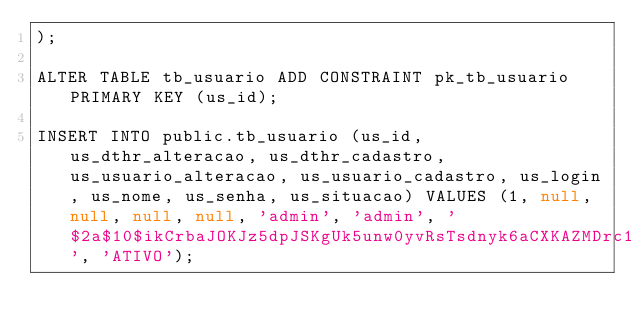<code> <loc_0><loc_0><loc_500><loc_500><_SQL_>);

ALTER TABLE tb_usuario ADD CONSTRAINT pk_tb_usuario PRIMARY KEY (us_id);

INSERT INTO public.tb_usuario (us_id, us_dthr_alteracao, us_dthr_cadastro, us_usuario_alteracao, us_usuario_cadastro, us_login, us_nome, us_senha, us_situacao) VALUES (1, null, null, null, null, 'admin', 'admin', '$2a$10$ikCrbaJOKJz5dpJSKgUk5unw0yvRsTsdnyk6aCXKAZMDrc1ePVkmu', 'ATIVO');</code> 